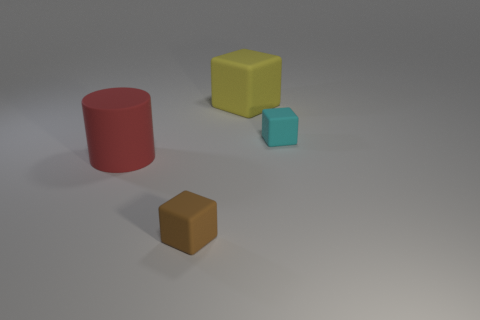Subtract all yellow cubes. How many cubes are left? 2 Subtract 1 cubes. How many cubes are left? 2 Add 3 small cylinders. How many objects exist? 7 Subtract all cubes. How many objects are left? 1 Subtract all gray cubes. Subtract all cyan cylinders. How many cubes are left? 3 Subtract all tiny blocks. Subtract all large yellow blocks. How many objects are left? 1 Add 2 tiny brown matte blocks. How many tiny brown matte blocks are left? 3 Add 1 brown cylinders. How many brown cylinders exist? 1 Subtract 0 red balls. How many objects are left? 4 